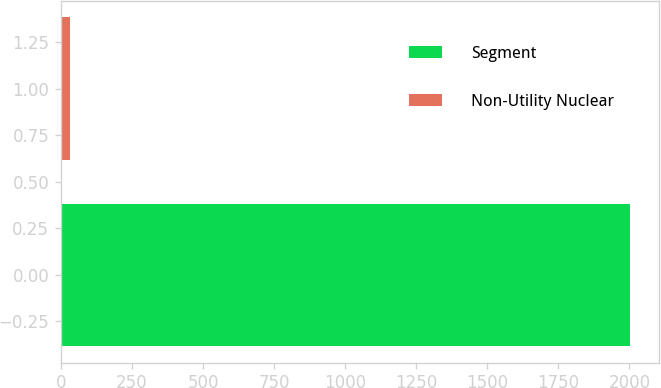Convert chart to OTSL. <chart><loc_0><loc_0><loc_500><loc_500><bar_chart><fcel>Segment<fcel>Non-Utility Nuclear<nl><fcel>2003<fcel>32<nl></chart> 